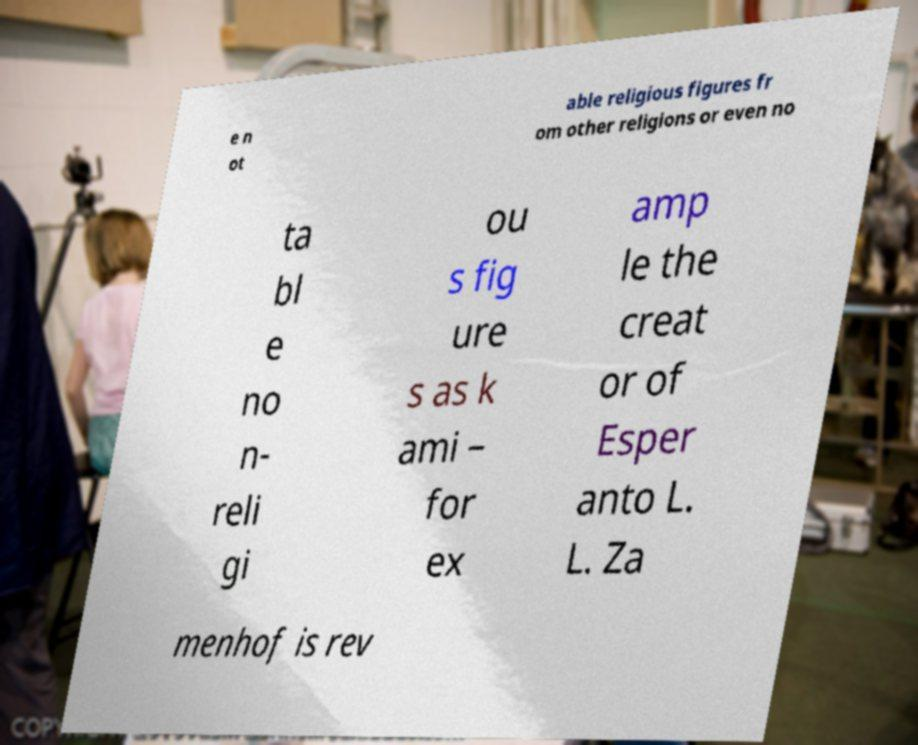Can you read and provide the text displayed in the image?This photo seems to have some interesting text. Can you extract and type it out for me? e n ot able religious figures fr om other religions or even no ta bl e no n- reli gi ou s fig ure s as k ami – for ex amp le the creat or of Esper anto L. L. Za menhof is rev 